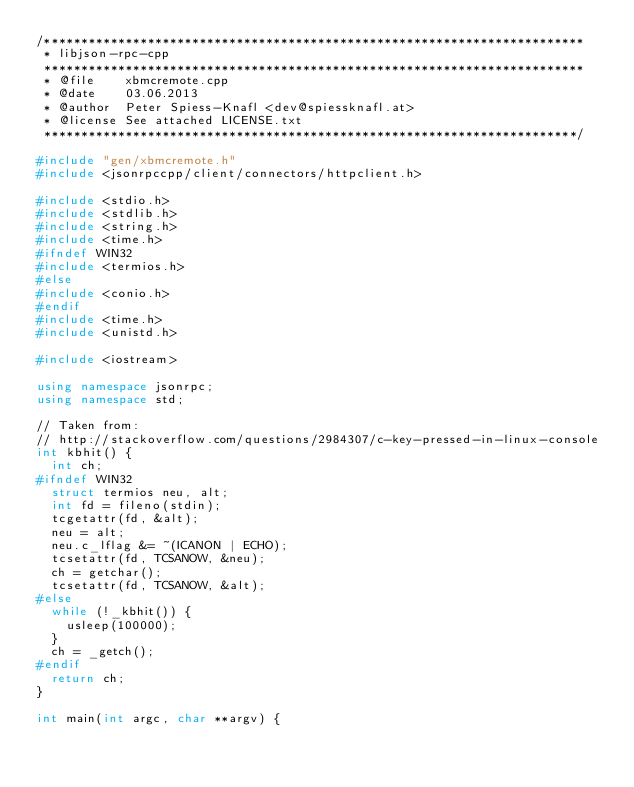Convert code to text. <code><loc_0><loc_0><loc_500><loc_500><_C++_>/*************************************************************************
 * libjson-rpc-cpp
 *************************************************************************
 * @file    xbmcremote.cpp
 * @date    03.06.2013
 * @author  Peter Spiess-Knafl <dev@spiessknafl.at>
 * @license See attached LICENSE.txt
 ************************************************************************/

#include "gen/xbmcremote.h"
#include <jsonrpccpp/client/connectors/httpclient.h>

#include <stdio.h>
#include <stdlib.h>
#include <string.h>
#include <time.h>
#ifndef WIN32
#include <termios.h>
#else
#include <conio.h>
#endif
#include <time.h>
#include <unistd.h>

#include <iostream>

using namespace jsonrpc;
using namespace std;

// Taken from:
// http://stackoverflow.com/questions/2984307/c-key-pressed-in-linux-console
int kbhit() {
  int ch;
#ifndef WIN32
  struct termios neu, alt;
  int fd = fileno(stdin);
  tcgetattr(fd, &alt);
  neu = alt;
  neu.c_lflag &= ~(ICANON | ECHO);
  tcsetattr(fd, TCSANOW, &neu);
  ch = getchar();
  tcsetattr(fd, TCSANOW, &alt);
#else
  while (!_kbhit()) {
    usleep(100000);
  }
  ch = _getch();
#endif
  return ch;
}

int main(int argc, char **argv) {
</code> 